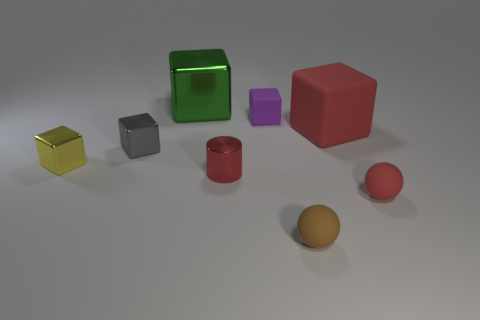There is a purple thing that is made of the same material as the small brown sphere; what size is it?
Your response must be concise. Small. Are there any tiny purple rubber blocks in front of the brown ball?
Keep it short and to the point. No. Does the green thing have the same shape as the red metallic thing?
Ensure brevity in your answer.  No. What size is the red rubber object that is left of the small red thing that is in front of the metal object to the right of the large green block?
Give a very brief answer. Large. What material is the green object?
Provide a short and direct response. Metal. What is the size of the ball that is the same color as the large matte block?
Make the answer very short. Small. There is a brown rubber thing; is its shape the same as the large object that is behind the small purple rubber object?
Make the answer very short. No. What material is the cube behind the matte cube on the left side of the big thing that is on the right side of the large green metallic block?
Offer a terse response. Metal. How many red balls are there?
Your answer should be compact. 1. How many red things are matte things or metallic things?
Your answer should be compact. 3. 